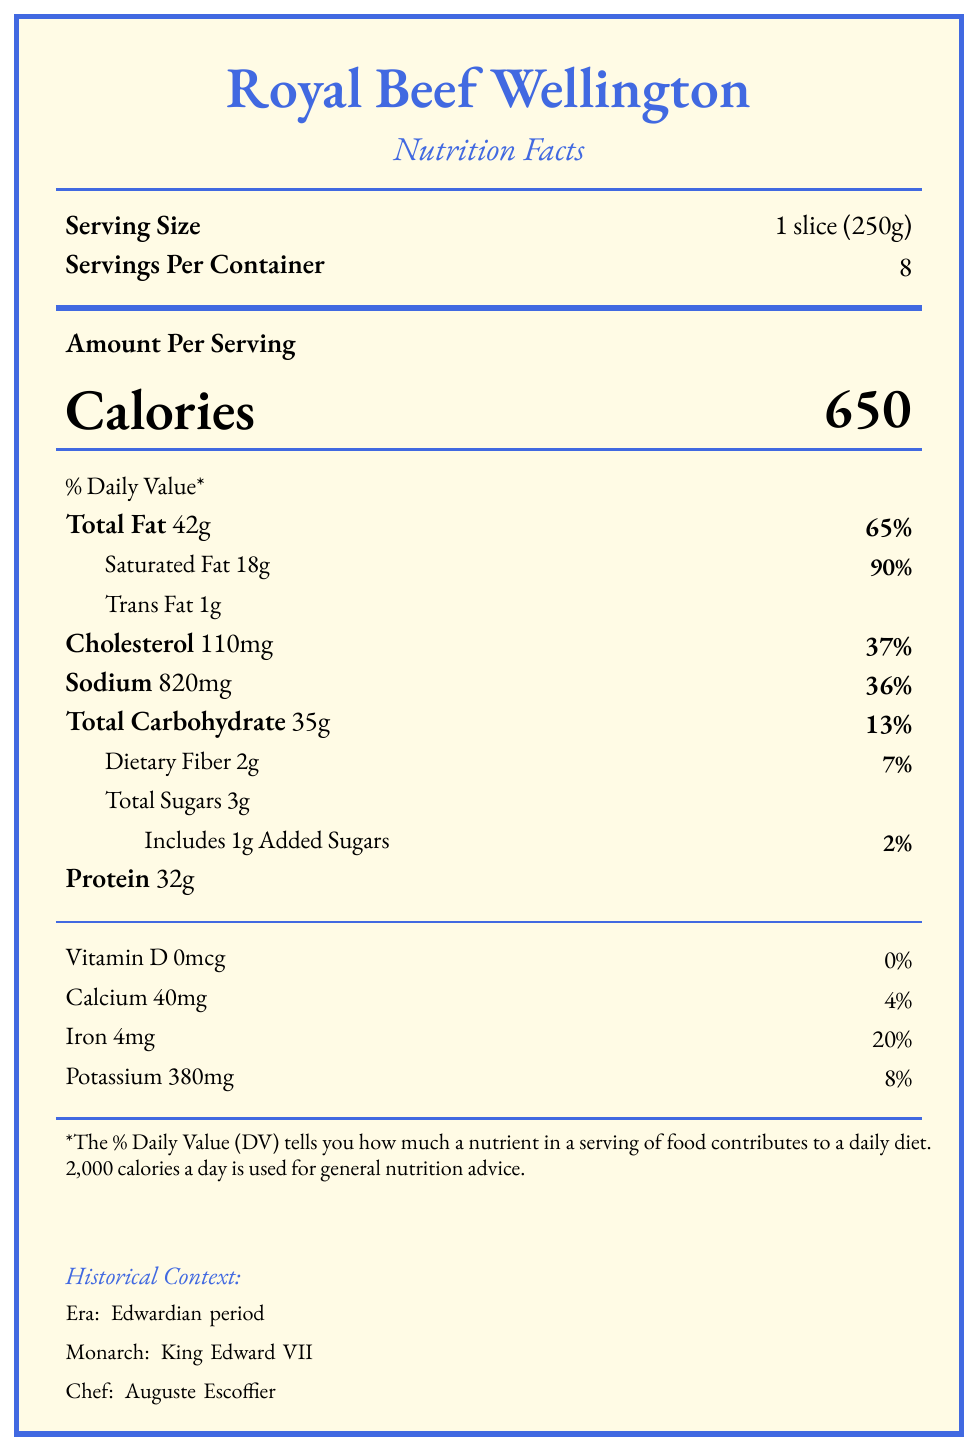What is the serving size for Royal Beef Wellington? The serving size is explicitly mentioned as 1 slice (250g) in the document.
Answer: 1 slice (250g) How many servings are there in one container of Royal Beef Wellington? The document states that there are 8 servings per container.
Answer: 8 How many calories are in one serving of Royal Beef Wellington? The document lists the calorie content per serving as 650 calories.
Answer: 650 What is the percentage of daily value for total fat? The document indicates that the total fat content per serving is 42g, which constitutes 65% of the daily value.
Answer: 65% Who was the chef associated with Royal Beef Wellington during the Edwardian period? The document mentions that Auguste Escoffier was the chef during the Edwardian period.
Answer: Auguste Escoffier How much sodium is present in one serving of Royal Beef Wellington? The sodium content is provided as 820mg per serving in the document.
Answer: 820mg What is the primary source of calories in Royal Beef Wellington? A. Protein B. Carbohydrates C. Fat D. Sugars The document notes that the primary source of calories comes from fat in beef and pastry.
Answer: C. Fat Which monarch was in power during the Edwardian period when the Royal Beef Wellington was popular? A. King George V B. Queen Victoria C. King Edward VII D. King George VI The document specifies that King Edward VII was the monarch during the Edwardian period.
Answer: C. King Edward VII What is the cholesterol content per serving? The document lists the cholesterol content as 110mg per serving.
Answer: 110mg Is there any vitamin D in Royal Beef Wellington? The document clearly states that the vitamin D content is 0mcg.
Answer: No Please summarize the nutritional content and historical significance of Royal Beef Wellington. The summary covers the key nutritional facts such as calories, fat, cholesterol, and sodium content per serving, and also highlights the historical aspects like its popularity, the era it was served in, and its cultural significance.
Answer: Royal Beef Wellington contains 650 calories per slice, with high levels of fat, cholesterol, and sodium, reflecting its meat-centric composition. Historically, it was a popular dish during the Edwardian period under King Edward VII, prepared by chef Auguste Escoffier, symbolizing wealth and used diplomatically to showcase British cuisine. What are the historical culinary influences on Royal Beef Wellington? The document provides details on the historical context of the dish during the Edwardian period and mentions the chef, but it does not provide comprehensive information on the historical culinary influences affecting the creation of the dish.
Answer: Not enough information 